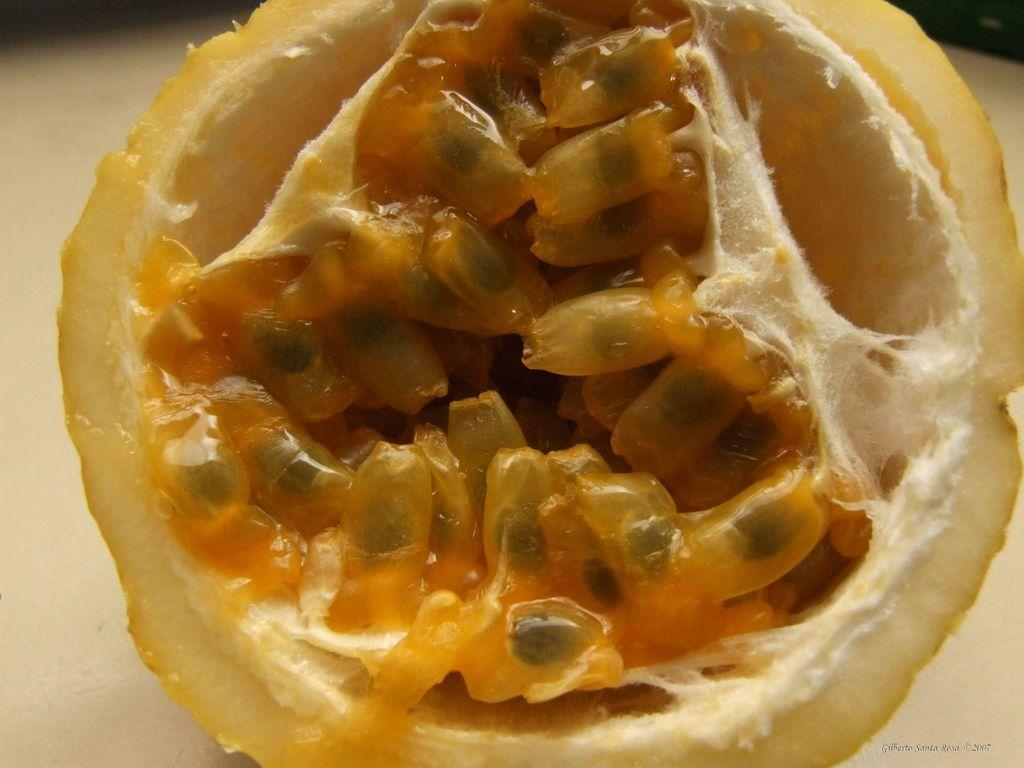What is the main subject in the image? There is a fruit slice in the image. Can you describe the background of the image? The background of the image is blurry. How many horns can be seen on the fruit slice in the image? There are no horns present on the fruit slice in the image. What type of chair is visible in the image? There is no chair present in the image. 